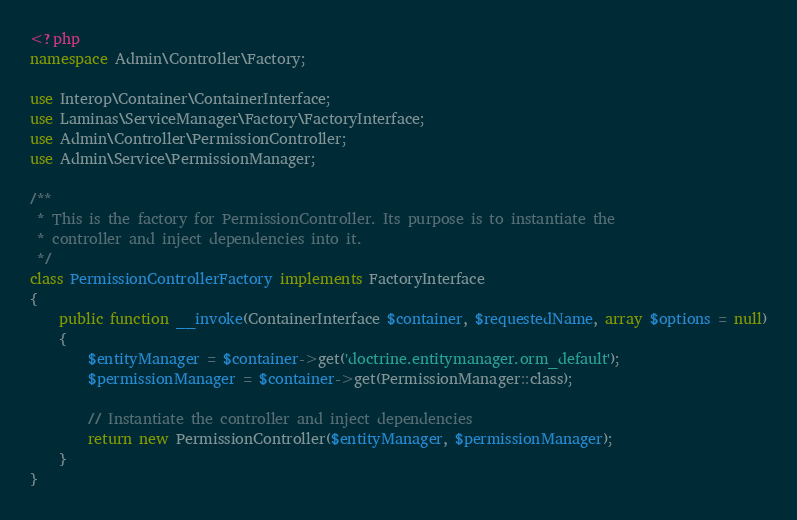<code> <loc_0><loc_0><loc_500><loc_500><_PHP_><?php
namespace Admin\Controller\Factory;

use Interop\Container\ContainerInterface;
use Laminas\ServiceManager\Factory\FactoryInterface;
use Admin\Controller\PermissionController;
use Admin\Service\PermissionManager;

/**
 * This is the factory for PermissionController. Its purpose is to instantiate the
 * controller and inject dependencies into it.
 */
class PermissionControllerFactory implements FactoryInterface
{
    public function __invoke(ContainerInterface $container, $requestedName, array $options = null)
    {
        $entityManager = $container->get('doctrine.entitymanager.orm_default');
        $permissionManager = $container->get(PermissionManager::class);
        
        // Instantiate the controller and inject dependencies
        return new PermissionController($entityManager, $permissionManager);
    }
}



</code> 